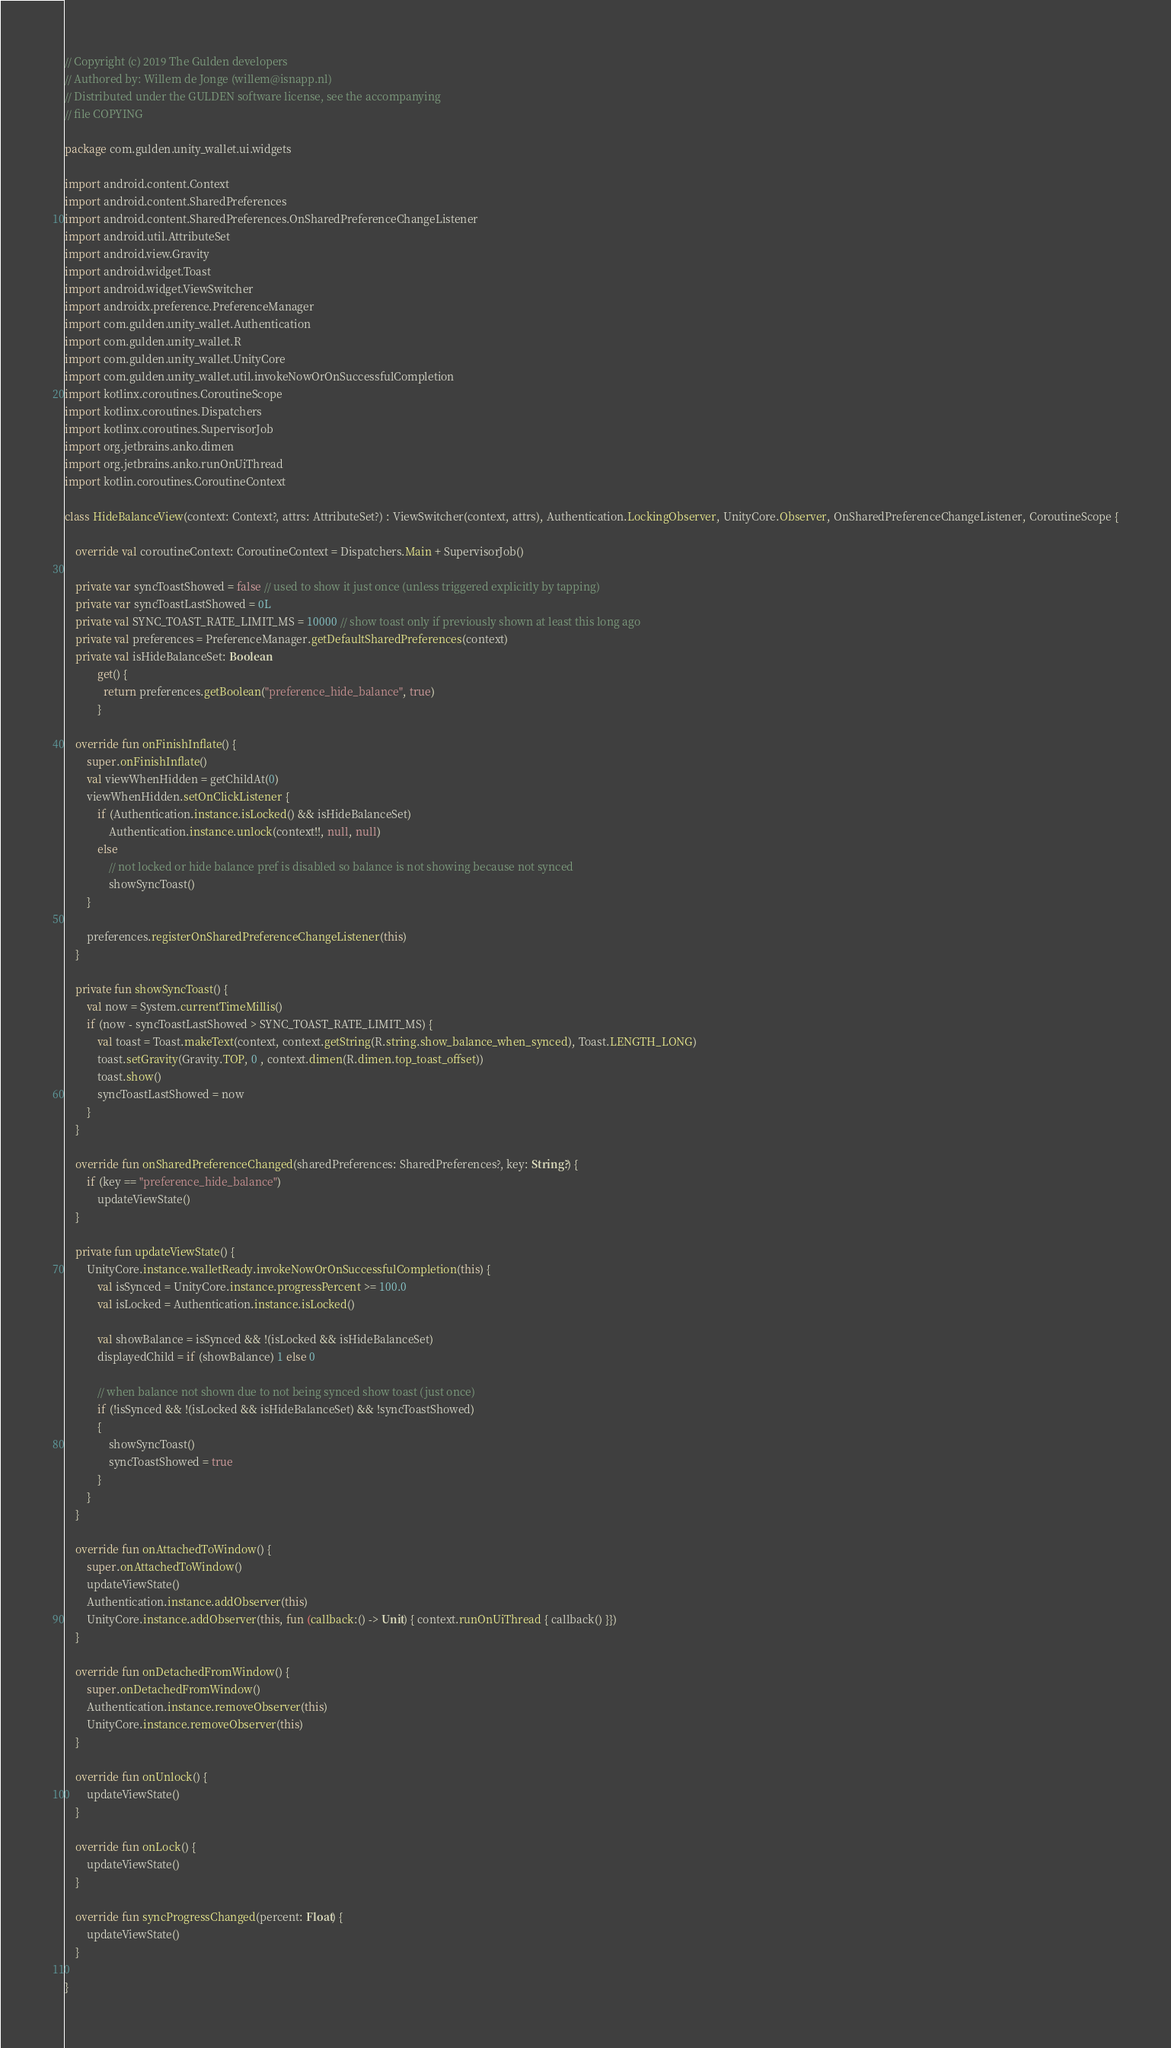<code> <loc_0><loc_0><loc_500><loc_500><_Kotlin_>// Copyright (c) 2019 The Gulden developers
// Authored by: Willem de Jonge (willem@isnapp.nl)
// Distributed under the GULDEN software license, see the accompanying
// file COPYING

package com.gulden.unity_wallet.ui.widgets

import android.content.Context
import android.content.SharedPreferences
import android.content.SharedPreferences.OnSharedPreferenceChangeListener
import android.util.AttributeSet
import android.view.Gravity
import android.widget.Toast
import android.widget.ViewSwitcher
import androidx.preference.PreferenceManager
import com.gulden.unity_wallet.Authentication
import com.gulden.unity_wallet.R
import com.gulden.unity_wallet.UnityCore
import com.gulden.unity_wallet.util.invokeNowOrOnSuccessfulCompletion
import kotlinx.coroutines.CoroutineScope
import kotlinx.coroutines.Dispatchers
import kotlinx.coroutines.SupervisorJob
import org.jetbrains.anko.dimen
import org.jetbrains.anko.runOnUiThread
import kotlin.coroutines.CoroutineContext

class HideBalanceView(context: Context?, attrs: AttributeSet?) : ViewSwitcher(context, attrs), Authentication.LockingObserver, UnityCore.Observer, OnSharedPreferenceChangeListener, CoroutineScope {

    override val coroutineContext: CoroutineContext = Dispatchers.Main + SupervisorJob()

    private var syncToastShowed = false // used to show it just once (unless triggered explicitly by tapping)
    private var syncToastLastShowed = 0L
    private val SYNC_TOAST_RATE_LIMIT_MS = 10000 // show toast only if previously shown at least this long ago
    private val preferences = PreferenceManager.getDefaultSharedPreferences(context)
    private val isHideBalanceSet: Boolean
            get() {
              return preferences.getBoolean("preference_hide_balance", true)
            }

    override fun onFinishInflate() {
        super.onFinishInflate()
        val viewWhenHidden = getChildAt(0)
        viewWhenHidden.setOnClickListener {
            if (Authentication.instance.isLocked() && isHideBalanceSet)
                Authentication.instance.unlock(context!!, null, null)
            else
                // not locked or hide balance pref is disabled so balance is not showing because not synced
                showSyncToast()
        }

        preferences.registerOnSharedPreferenceChangeListener(this)
    }

    private fun showSyncToast() {
        val now = System.currentTimeMillis()
        if (now - syncToastLastShowed > SYNC_TOAST_RATE_LIMIT_MS) {
            val toast = Toast.makeText(context, context.getString(R.string.show_balance_when_synced), Toast.LENGTH_LONG)
            toast.setGravity(Gravity.TOP, 0 , context.dimen(R.dimen.top_toast_offset))
            toast.show()
            syncToastLastShowed = now
        }
    }

    override fun onSharedPreferenceChanged(sharedPreferences: SharedPreferences?, key: String?) {
        if (key == "preference_hide_balance")
            updateViewState()
    }

    private fun updateViewState() {
        UnityCore.instance.walletReady.invokeNowOrOnSuccessfulCompletion(this) {
            val isSynced = UnityCore.instance.progressPercent >= 100.0
            val isLocked = Authentication.instance.isLocked()

            val showBalance = isSynced && !(isLocked && isHideBalanceSet)
            displayedChild = if (showBalance) 1 else 0

            // when balance not shown due to not being synced show toast (just once)
            if (!isSynced && !(isLocked && isHideBalanceSet) && !syncToastShowed)
            {
                showSyncToast()
                syncToastShowed = true
            }
        }
    }

    override fun onAttachedToWindow() {
        super.onAttachedToWindow()
        updateViewState()
        Authentication.instance.addObserver(this)
        UnityCore.instance.addObserver(this, fun (callback:() -> Unit) { context.runOnUiThread { callback() }})
    }

    override fun onDetachedFromWindow() {
        super.onDetachedFromWindow()
        Authentication.instance.removeObserver(this)
        UnityCore.instance.removeObserver(this)
    }

    override fun onUnlock() {
        updateViewState()
    }

    override fun onLock() {
        updateViewState()
    }

    override fun syncProgressChanged(percent: Float) {
        updateViewState()
    }

}
</code> 